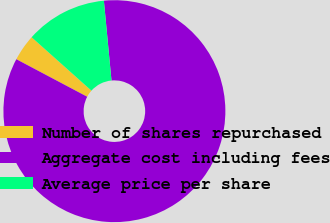Convert chart to OTSL. <chart><loc_0><loc_0><loc_500><loc_500><pie_chart><fcel>Number of shares repurchased<fcel>Aggregate cost including fees<fcel>Average price per share<nl><fcel>3.85%<fcel>84.26%<fcel>11.89%<nl></chart> 